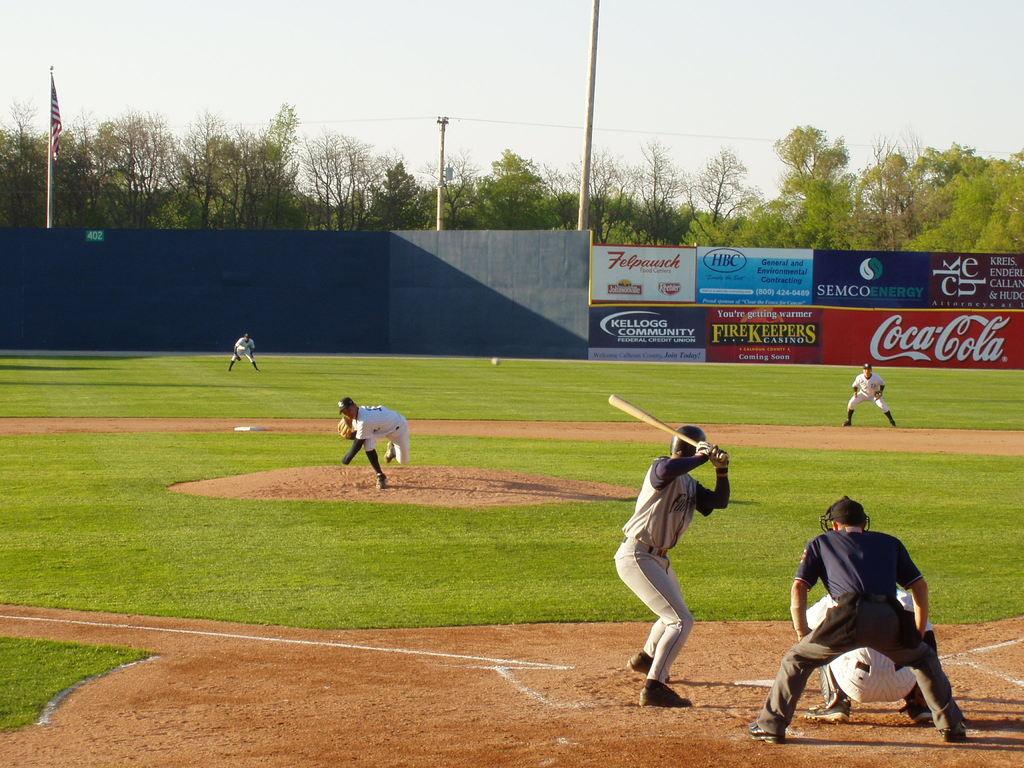What is the beverage brand on the advertisement  banner?
Keep it short and to the point. Coca-cola. What brand is advertised on the center bottom banner?
Your answer should be compact. Firekeepers. 